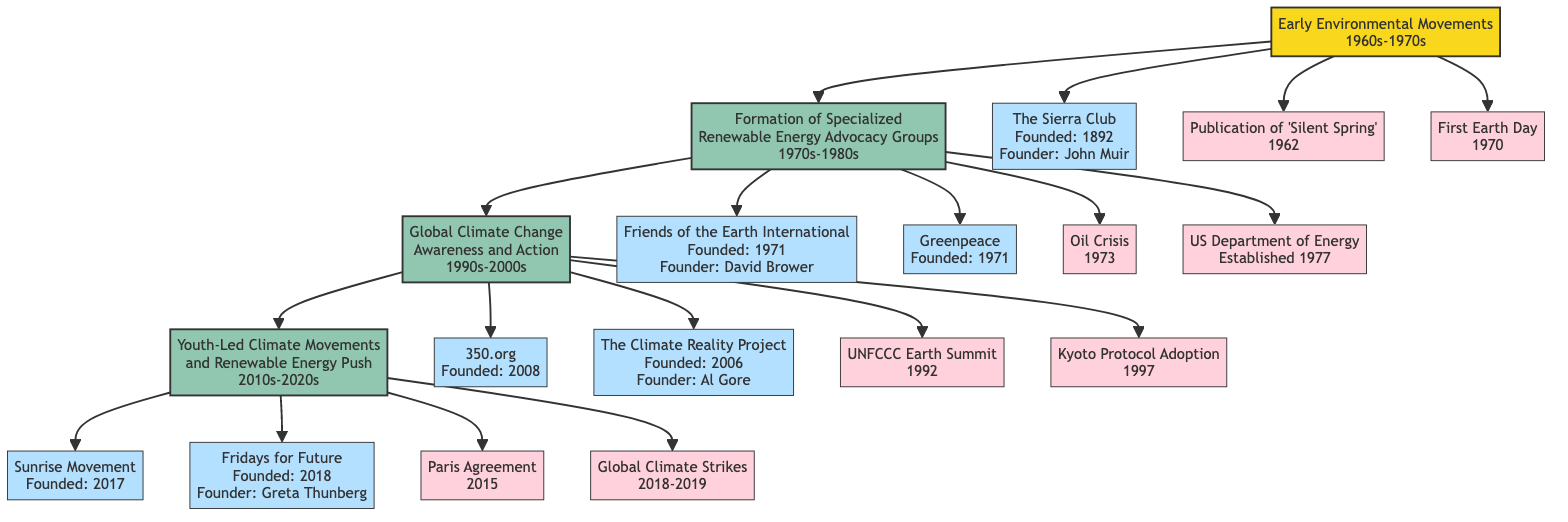What is the first advocacy group mentioned in the diagram? The diagram starts with the "Early Environmental Movements" root node, under which "The Sierra Club" is listed as the first advocacy group.
Answer: The Sierra Club What year was "Friends of the Earth International" founded? In the diagram, "Friends of the Earth International" is listed under the node for the 1970s-1980s time period with a founding year of 1971.
Answer: 1971 How many key events are associated with the 1990s-2000s time period? By examining the node for the 1990s-2000s, there are four key events listed including the UNFCCC Earth Summit and the Kyoto Protocol Adoption, which adds up to the total count.
Answer: 4 Which organization was founded by Al Gore? Under the 1990s-2000s node, "The Climate Reality Project" is clearly mentioned as being founded by Al Gore.
Answer: The Climate Reality Project What major global agreement was established in 2015? The diagram mentions the "Paris Agreement" as a key event in the 2010s-2020s node, indicating it was established in 2015.
Answer: Paris Agreement Which decade saw the publication of "Silent Spring"? The event node directly states that "Silent Spring" was published in 1962, placing it within the 1960s-1970s time period.
Answer: 1960s-1970s Who are the founders of the Sunrise Movement? The node for the 2010s-2020s lists the founders of the Sunrise Movement as Varshini Prakash and Evan Weber.
Answer: Varshini Prakash, Evan Weber How many advocacy groups are there in the 1970s-1980s period? Counting the nodes under the 1970s-1980s section, specifically "Friends of the Earth International" and "Greenpeace," we find two distinct advocacy groups represented.
Answer: 2 Which event corresponds to the year 1973? The node for the 1970s-1980s indicates that the "Oil Crisis" occurred in the year 1973, making it easily identifiable as an event for that year.
Answer: Oil Crisis 